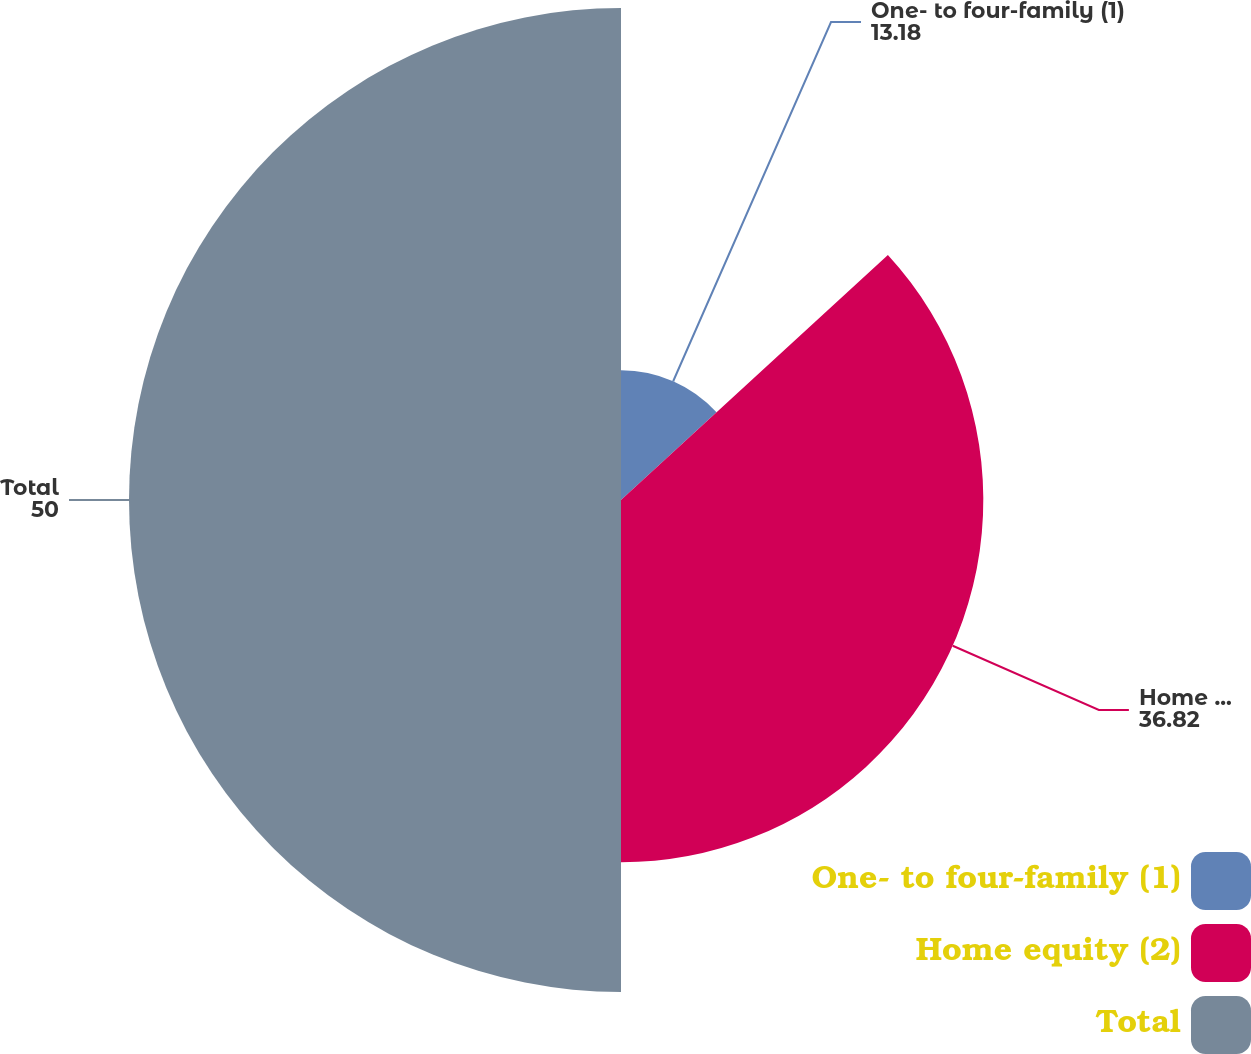Convert chart to OTSL. <chart><loc_0><loc_0><loc_500><loc_500><pie_chart><fcel>One- to four-family (1)<fcel>Home equity (2)<fcel>Total<nl><fcel>13.18%<fcel>36.82%<fcel>50.0%<nl></chart> 